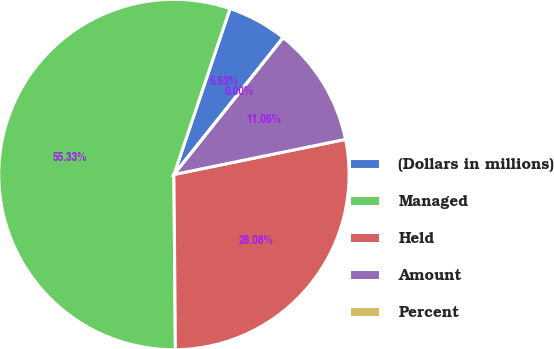Convert chart. <chart><loc_0><loc_0><loc_500><loc_500><pie_chart><fcel>(Dollars in millions)<fcel>Managed<fcel>Held<fcel>Amount<fcel>Percent<nl><fcel>5.53%<fcel>55.32%<fcel>28.08%<fcel>11.06%<fcel>0.0%<nl></chart> 